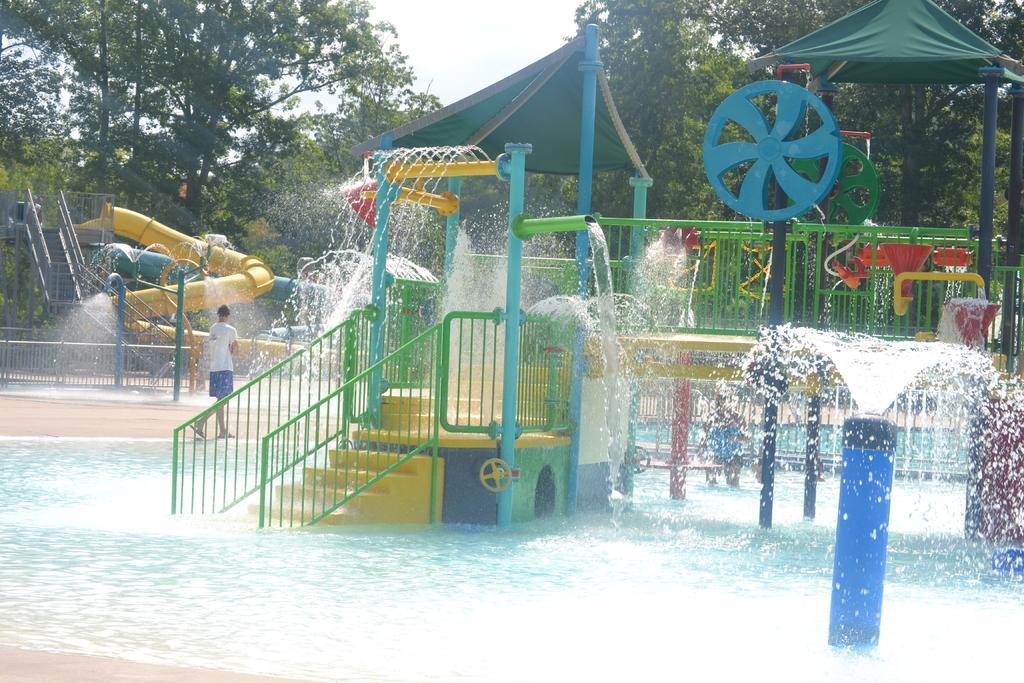Can you describe this image briefly? In this image we can see the water park, a person here, stairs, tents, trees and the sky in the background. 